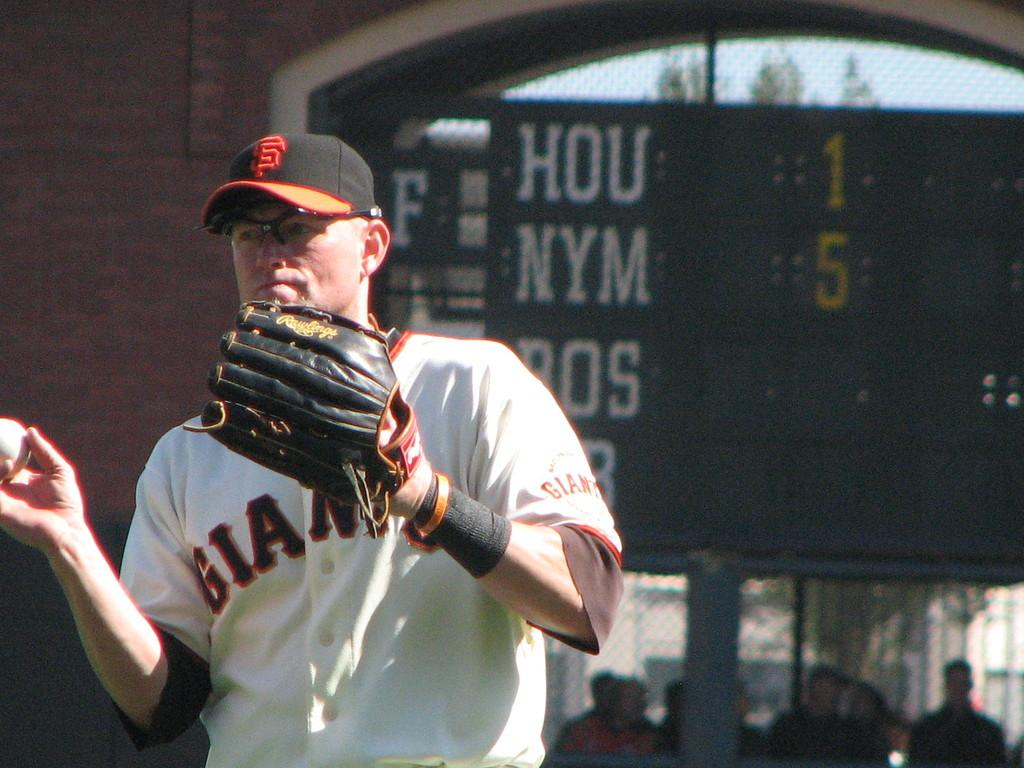<image>
Describe the image concisely. A San Francisco Giants baseball player with a catchers glove on one hand and a baseball in the other. 